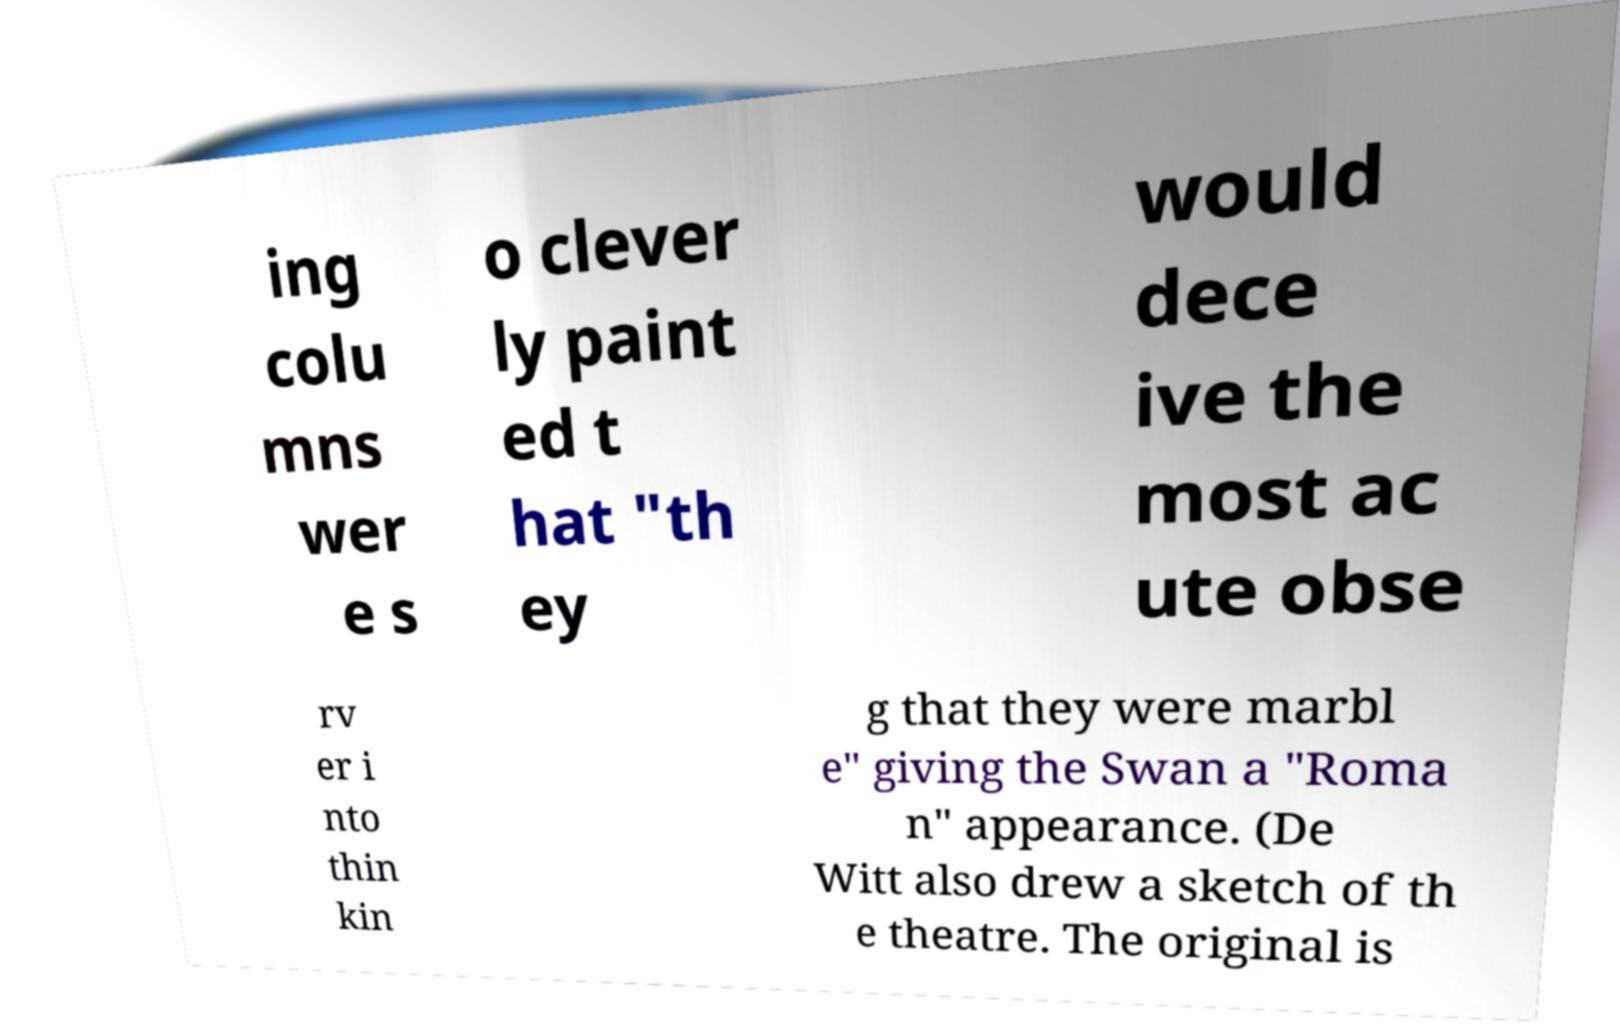I need the written content from this picture converted into text. Can you do that? ing colu mns wer e s o clever ly paint ed t hat "th ey would dece ive the most ac ute obse rv er i nto thin kin g that they were marbl e" giving the Swan a "Roma n" appearance. (De Witt also drew a sketch of th e theatre. The original is 